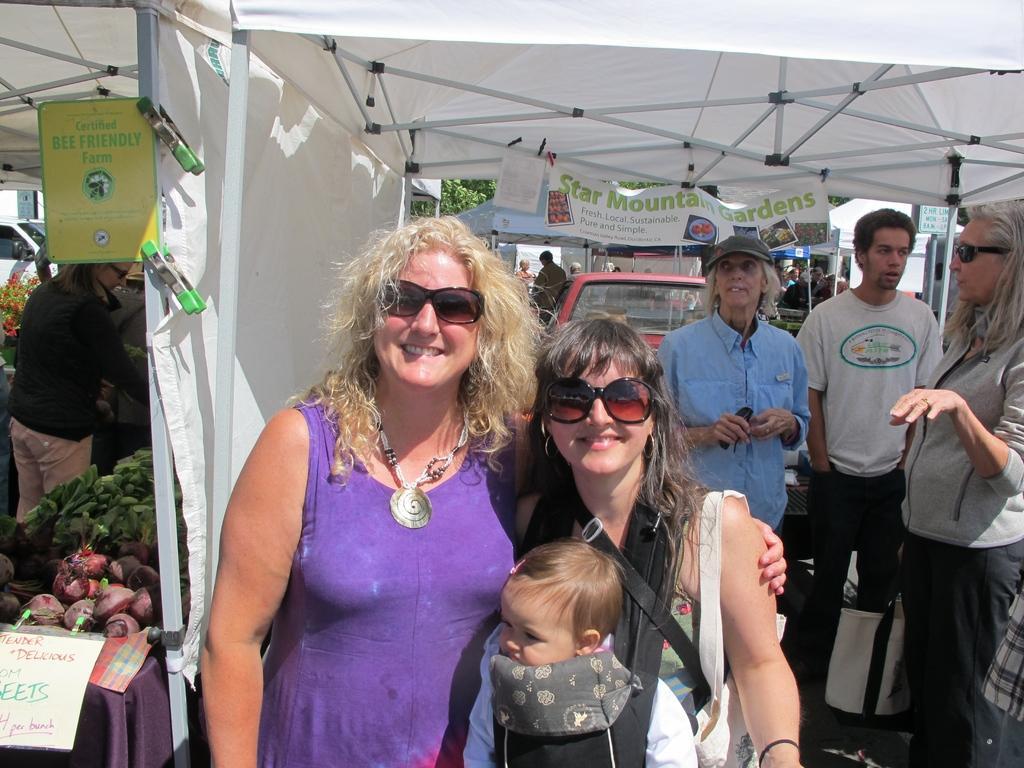Please provide a concise description of this image. Here men and women are standing, this is a child, this is a vehicle, there is poster, these are tents, there are vegetables. 